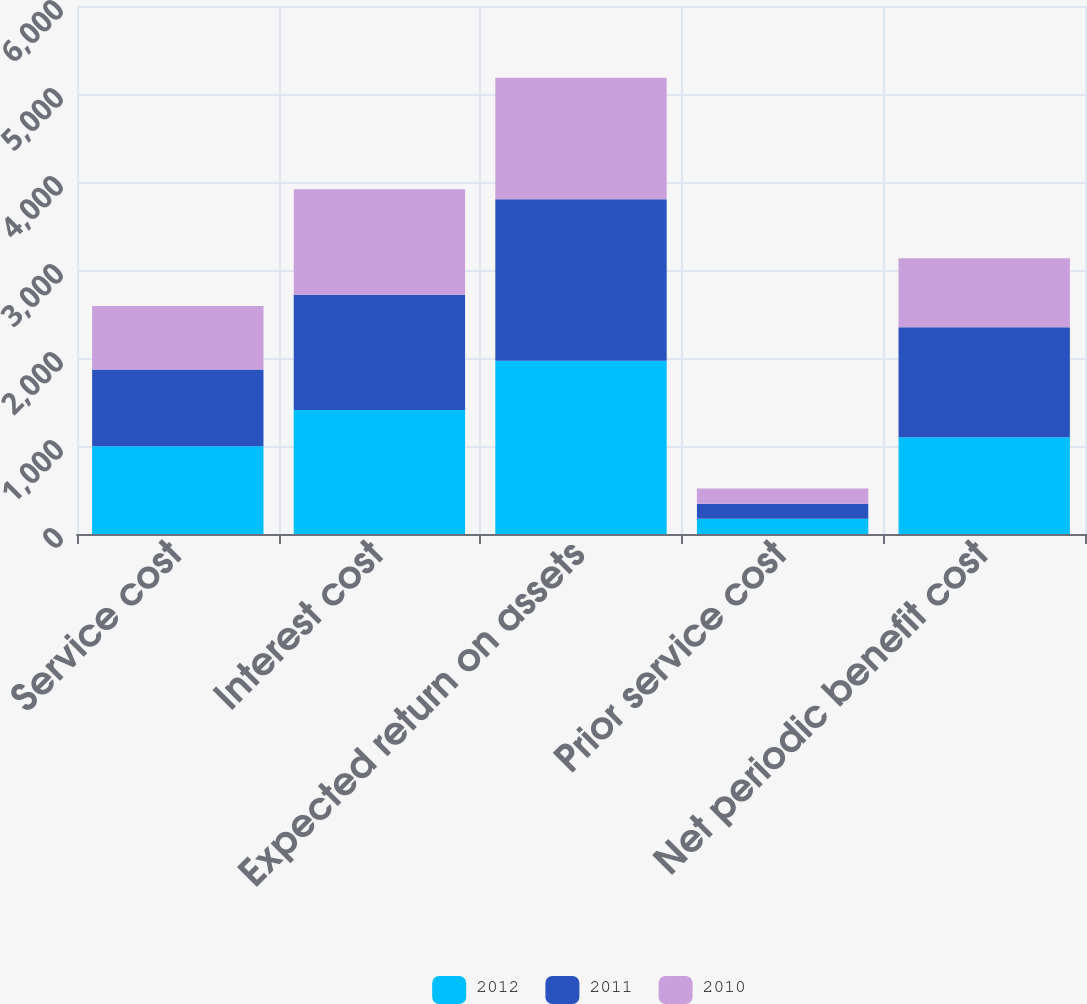Convert chart. <chart><loc_0><loc_0><loc_500><loc_500><stacked_bar_chart><ecel><fcel>Service cost<fcel>Interest cost<fcel>Expected return on assets<fcel>Prior service cost<fcel>Net periodic benefit cost<nl><fcel>2012<fcel>998<fcel>1410<fcel>1970<fcel>173<fcel>1098.5<nl><fcel>2011<fcel>870<fcel>1309<fcel>1835<fcel>171<fcel>1251<nl><fcel>2010<fcel>723<fcel>1199<fcel>1381<fcel>172<fcel>783<nl></chart> 